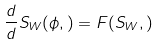Convert formula to latex. <formula><loc_0><loc_0><loc_500><loc_500>\L \frac { d } { d \L } S _ { W } ( \phi , \L ) = F ( S _ { W } , \L )</formula> 